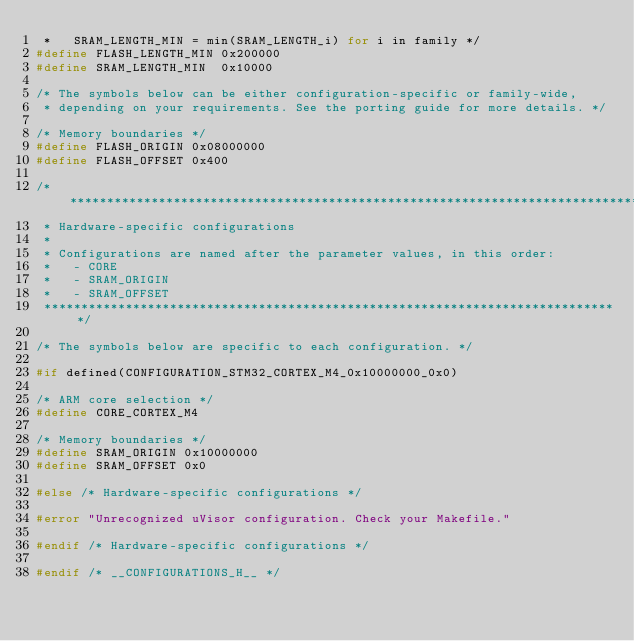Convert code to text. <code><loc_0><loc_0><loc_500><loc_500><_C_> *   SRAM_LENGTH_MIN = min(SRAM_LENGTH_i) for i in family */
#define FLASH_LENGTH_MIN 0x200000
#define SRAM_LENGTH_MIN  0x10000

/* The symbols below can be either configuration-specific or family-wide,
 * depending on your requirements. See the porting guide for more details. */

/* Memory boundaries */
#define FLASH_ORIGIN 0x08000000
#define FLASH_OFFSET 0x400

/*******************************************************************************
 * Hardware-specific configurations
 *
 * Configurations are named after the parameter values, in this order:
 *   - CORE
 *   - SRAM_ORIGIN
 *   - SRAM_OFFSET
 ******************************************************************************/

/* The symbols below are specific to each configuration. */

#if defined(CONFIGURATION_STM32_CORTEX_M4_0x10000000_0x0)

/* ARM core selection */
#define CORE_CORTEX_M4

/* Memory boundaries */
#define SRAM_ORIGIN 0x10000000
#define SRAM_OFFSET 0x0

#else /* Hardware-specific configurations */

#error "Unrecognized uVisor configuration. Check your Makefile."

#endif /* Hardware-specific configurations */

#endif /* __CONFIGURATIONS_H__ */
</code> 